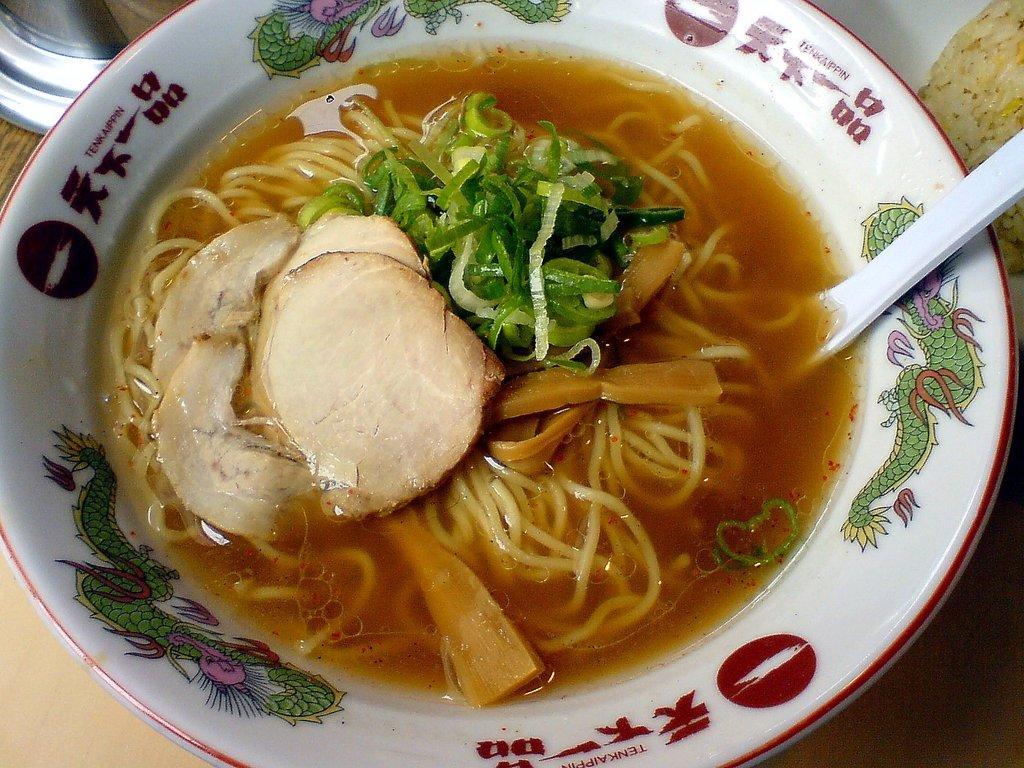In one or two sentences, can you explain what this image depicts? In this image there is a food item with a spoon in a bowl. 